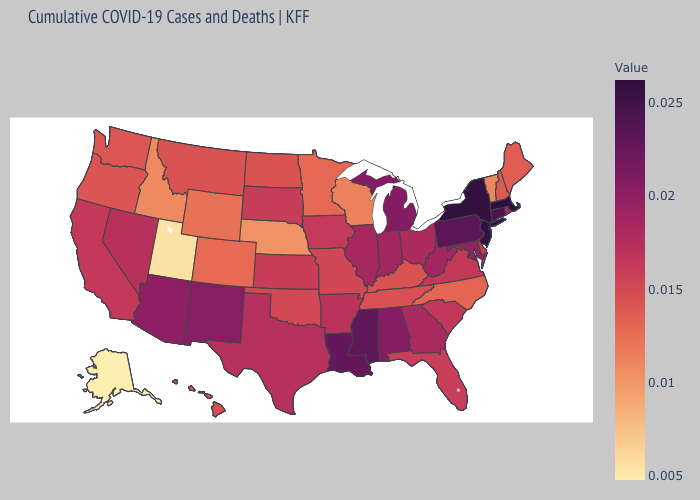Does Idaho have a lower value than Alabama?
Answer briefly. Yes. Which states have the highest value in the USA?
Short answer required. Massachusetts. Among the states that border Florida , does Alabama have the highest value?
Give a very brief answer. Yes. Among the states that border Mississippi , which have the lowest value?
Concise answer only. Tennessee. Which states have the lowest value in the USA?
Be succinct. Alaska. 